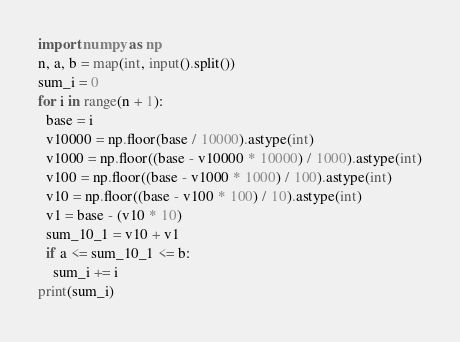<code> <loc_0><loc_0><loc_500><loc_500><_Python_>import numpy as np
n, a, b = map(int, input().split())
sum_i = 0
for i in range(n + 1):
  base = i
  v10000 = np.floor(base / 10000).astype(int)
  v1000 = np.floor((base - v10000 * 10000) / 1000).astype(int)
  v100 = np.floor((base - v1000 * 1000) / 100).astype(int)
  v10 = np.floor((base - v100 * 100) / 10).astype(int)
  v1 = base - (v10 * 10)
  sum_10_1 = v10 + v1
  if a <= sum_10_1 <= b:
    sum_i += i
print(sum_i)</code> 